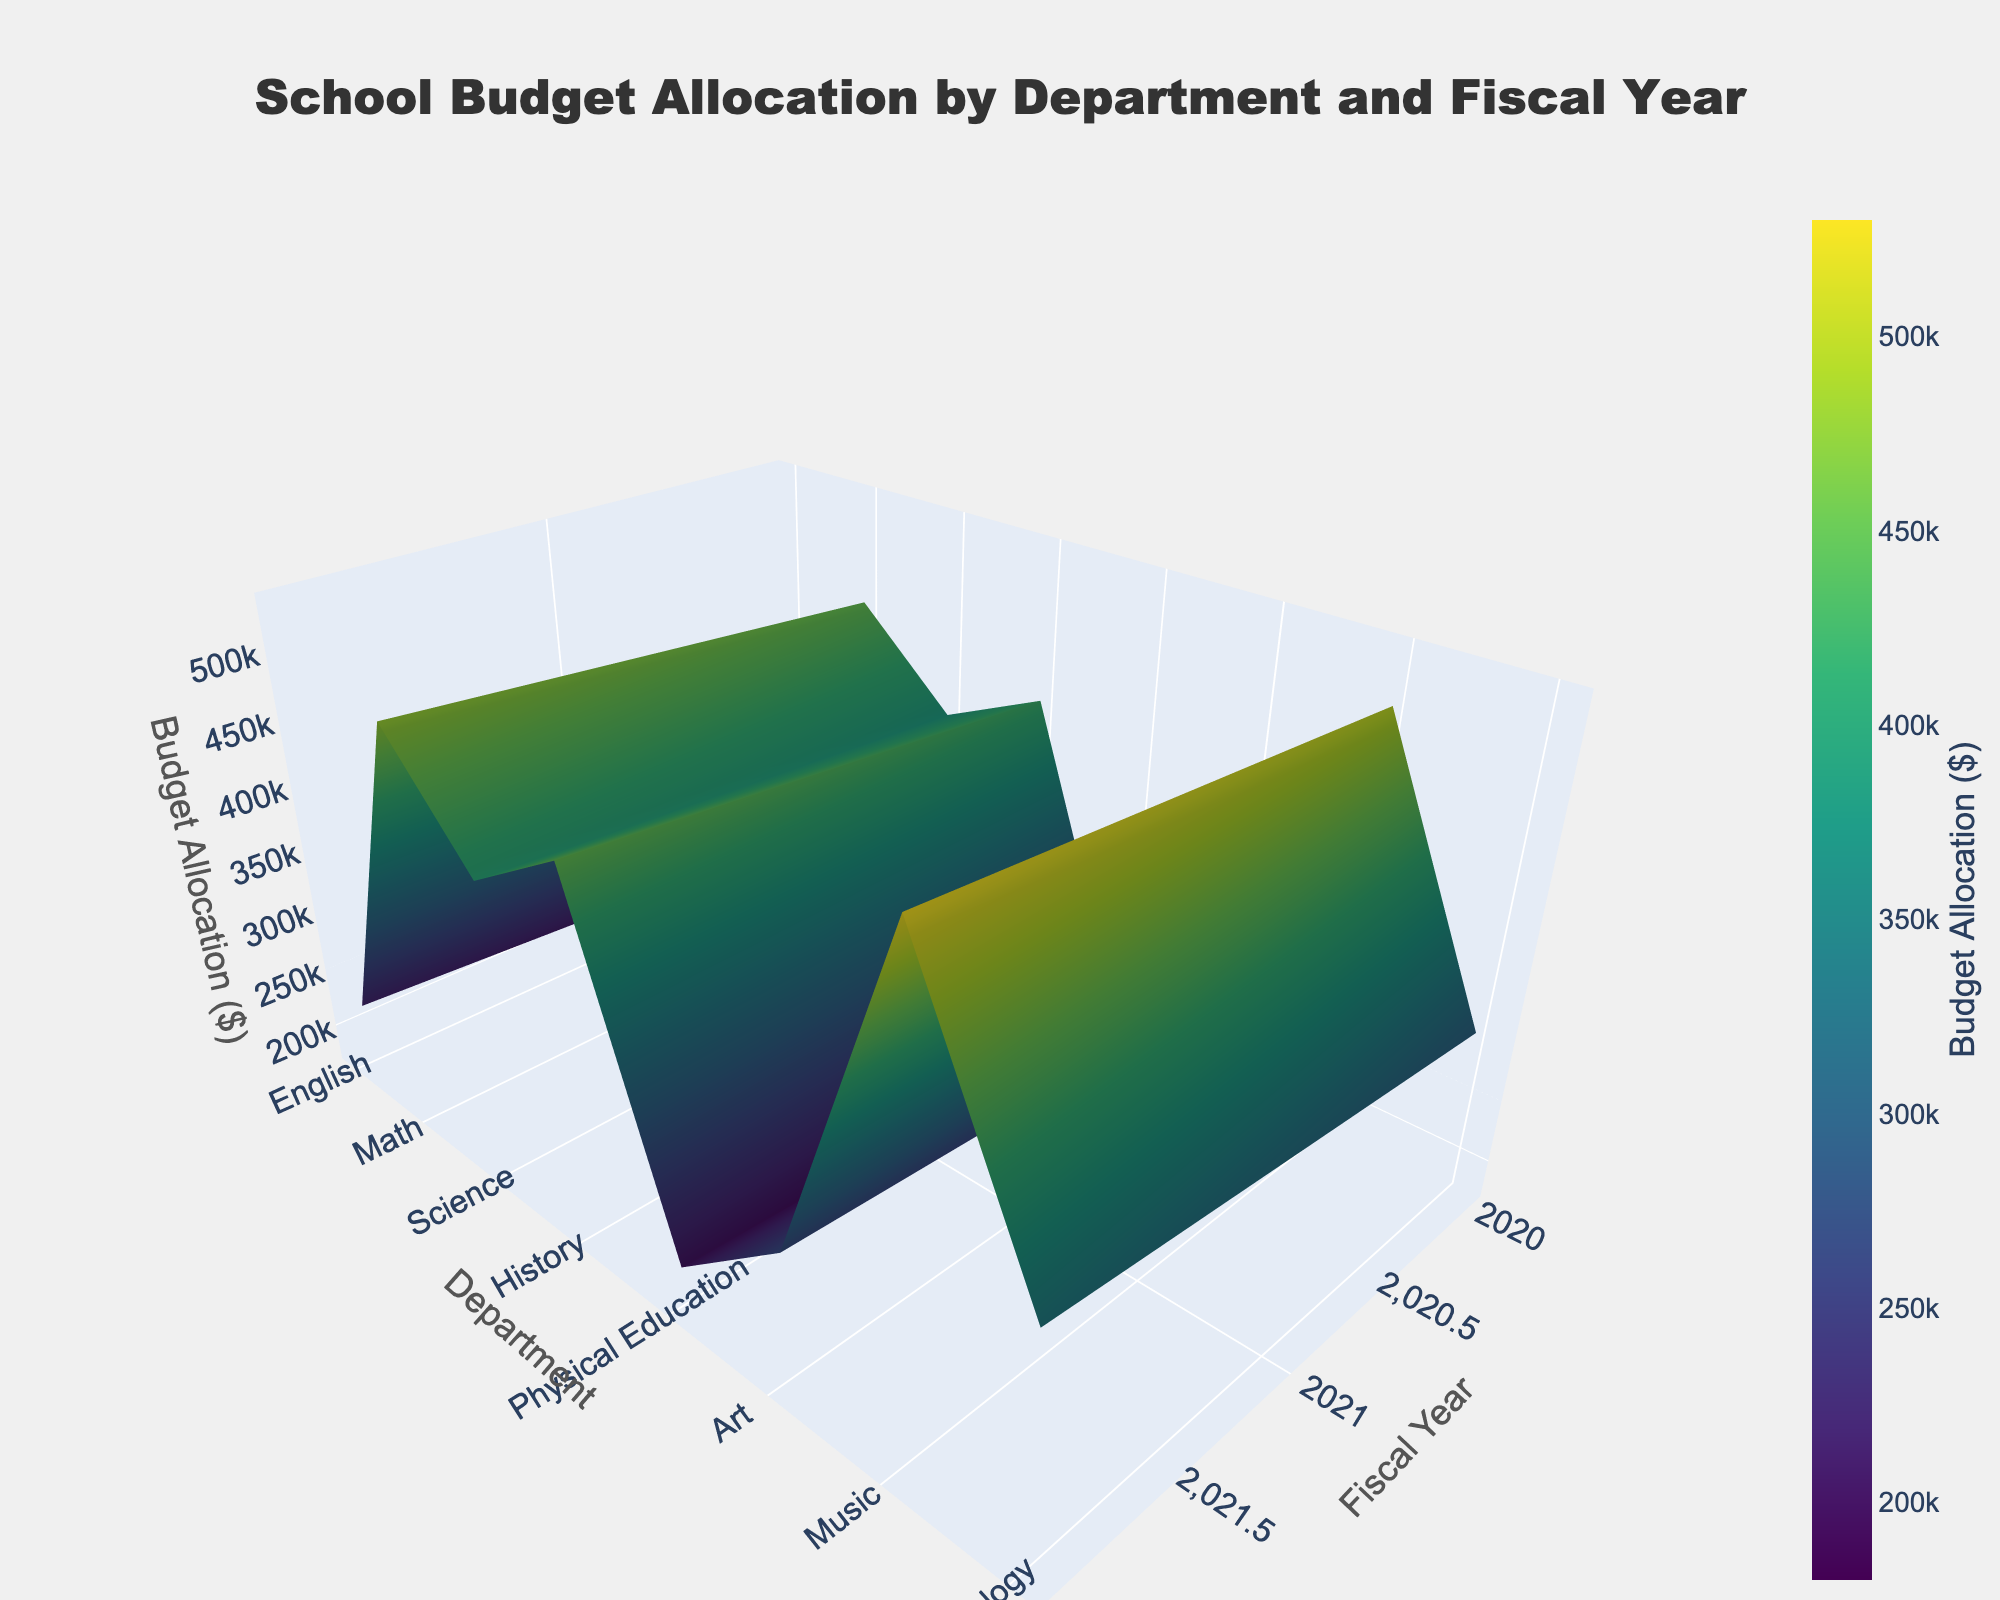What is the title of the 3D plot? The title of the plot is generally found at the top and is displayed prominently. In this case, it reads "School Budget Allocation by Department and Fiscal Year".
Answer: School Budget Allocation by Department and Fiscal Year Which department has the highest budget allocation in the year 2022? To find this, you need to examine the highest point on the surface in the year 2022. The highest peak in the 2022 x-axis belongs to the Science department.
Answer: Science How does the budget allocation for Math compare between the years 2020 and 2022? You need to compare the budget values of Math for 2020 and 2022 from the 3D surface. Math's budget in 2020 was lower than in 2022. Specifically, 420,000 in 2020 vs. 450,000 in 2022, showing an increase.
Answer: It increased Which fiscal year had the highest overall budget allocation across all departments? By visually inspecting the 3D plot surface for the year with overall highest z-values across most departments, we find that the year 2022 has the highest overall budget allocation.
Answer: 2022 What is the color used to indicate the highest budget allocations on the 3D surface plot? The color scale 'Viridis' starts with dark purple for the lowest values and ends with yellow/bright green for the highest values. Therefore, the highest budget allocations are indicated by yellow/bright green.
Answer: Yellow/Bright Green What is the range of budget allocations for the Physical Education department from 2020 to 2022? You need to observe the z-values for Physical Education over the years 2020 to 2022 on the plot. Physical Education's budget allocation ranges from 250,000 in 2020 to 270,000 in 2022, showing an increasing trend.
Answer: 250,000 to 270,000 Which department saw the smallest increase in budget allocation from 2020 to 2022? To determine this, compare the changes in budget allocations for all departments from 2020 to 2022. The Music department saw the smallest increase, going from 180,000 in 2020 to 200,000 in 2022, an increase of 20,000.
Answer: Music Is there any department whose budget allocation remained constant over the three years? By examining the surface plot for any departments where the z-values do not change over the fiscal years, we can see that all departments have varying budget allocations, meaning none stayed constant.
Answer: No Calculate the average budget allocation for the Art department over the years 2020, 2021, and 2022. To find the average, sum the Art department's budget allocations for the three years (200,000 + 210,000 + 220,000 = 630,000) and divide by 3. So, the average is 630,000 / 3 = 210,000.
Answer: 210,000 Compare the budget allocations for Technology and Art in the year 2021. Which one has a higher budget allocation? Look at the 3D plot specifically for the year 2021 and compare the z-values (budget allocations) for Technology (320,000) and Art (210,000). Technology has a higher budget allocation.
Answer: Technology 